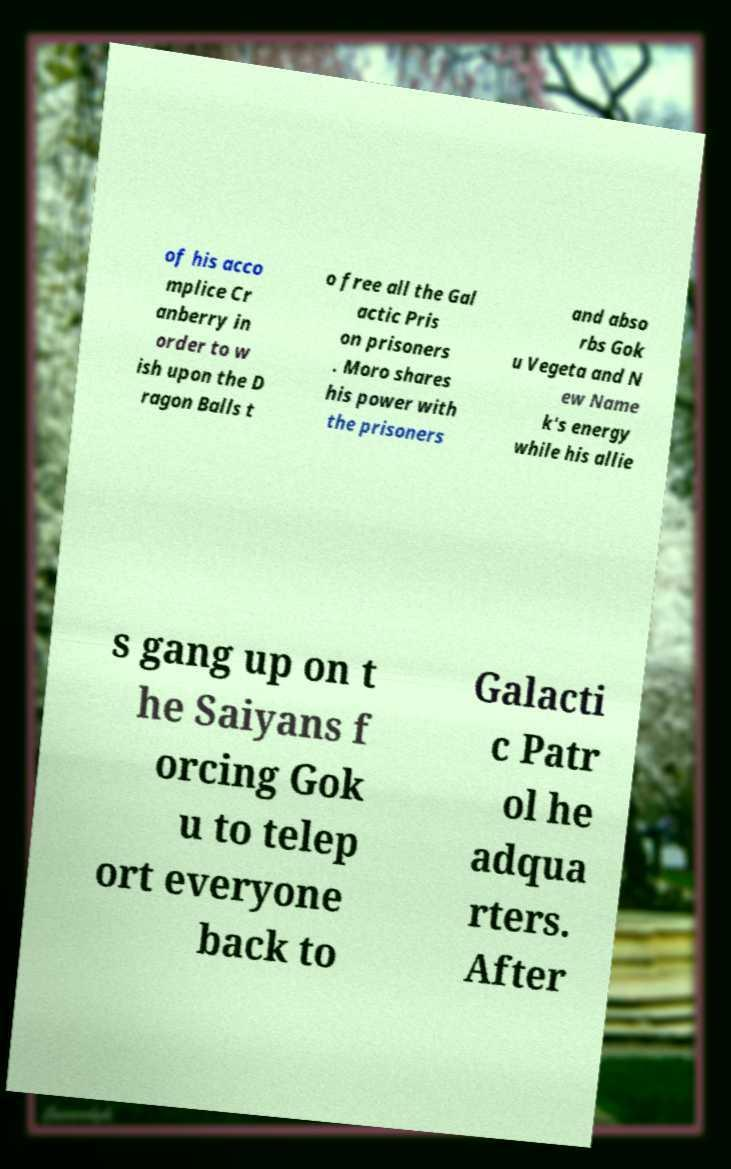Can you read and provide the text displayed in the image?This photo seems to have some interesting text. Can you extract and type it out for me? of his acco mplice Cr anberry in order to w ish upon the D ragon Balls t o free all the Gal actic Pris on prisoners . Moro shares his power with the prisoners and abso rbs Gok u Vegeta and N ew Name k's energy while his allie s gang up on t he Saiyans f orcing Gok u to telep ort everyone back to Galacti c Patr ol he adqua rters. After 